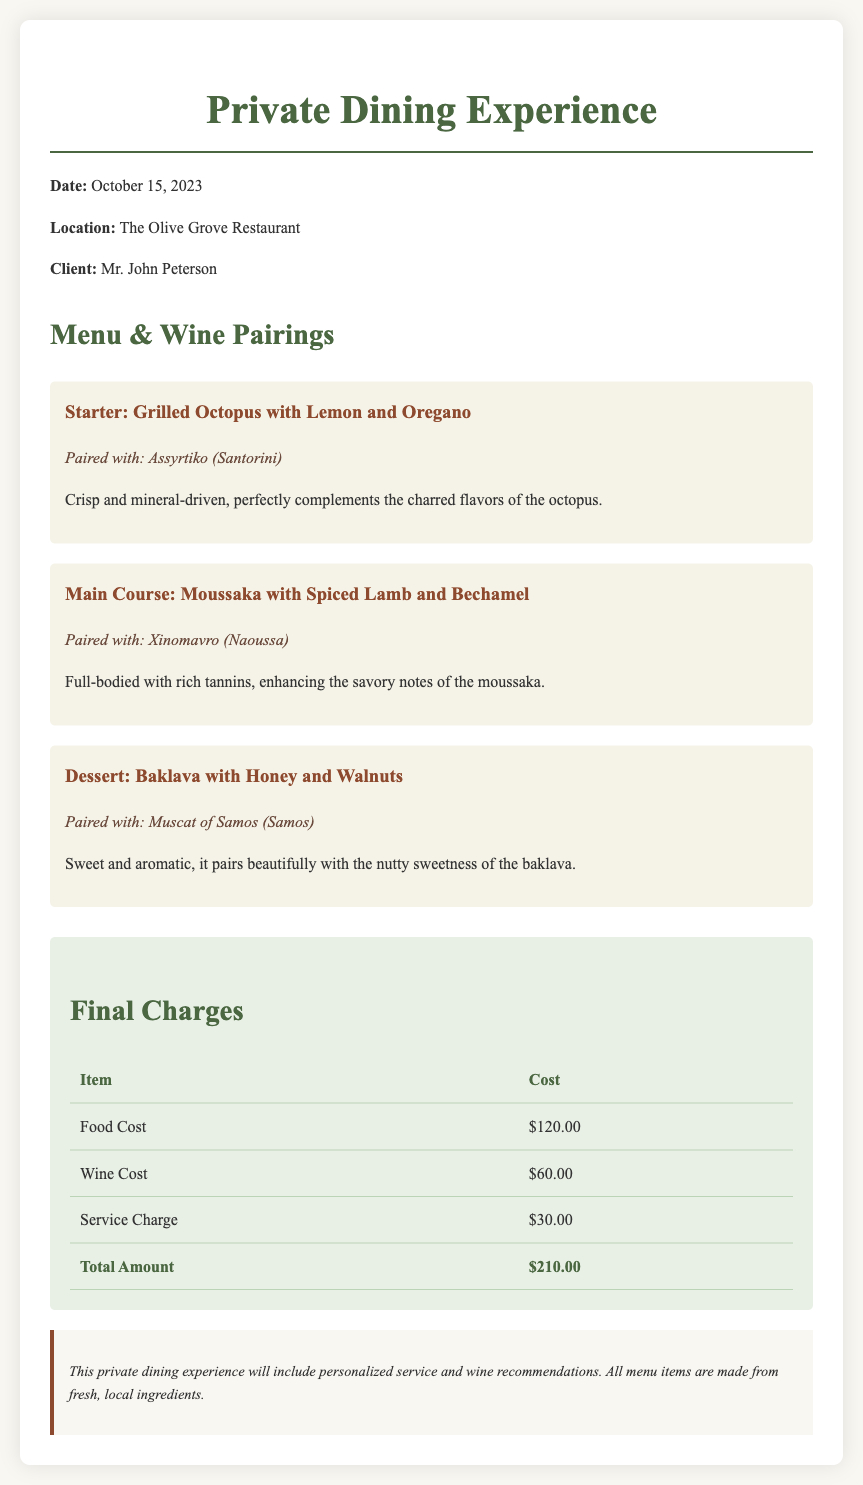What is the date of the private dining experience? The date is specified as October 15, 2023 in the document.
Answer: October 15, 2023 Who is the client for this dining experience? The document lists Mr. John Peterson as the client.
Answer: Mr. John Peterson What is the cost of food? The food cost is detailed in the charges section of the document, stated as $120.00.
Answer: $120.00 What wine is paired with the dessert? The dessert pairing is explicitly mentioned as Muscat of Samos (Samos) in the menu section.
Answer: Muscat of Samos (Samos) What is the total amount charged? The total amount can be found in the final charges table, which sums all expenses to $210.00.
Answer: $210.00 What type of service is included in this experience? The notes section mentions personalized service as part of the experience.
Answer: Personalized service Which dish is paired with Assyrtiko? The pairing of Assyrtiko is specified for the starter dish of grilled octopus.
Answer: Grilled Octopus with Lemon and Oregano What is noted about the ingredients used? The notes indicate that all menu items are made from fresh, local ingredients.
Answer: Fresh, local ingredients 